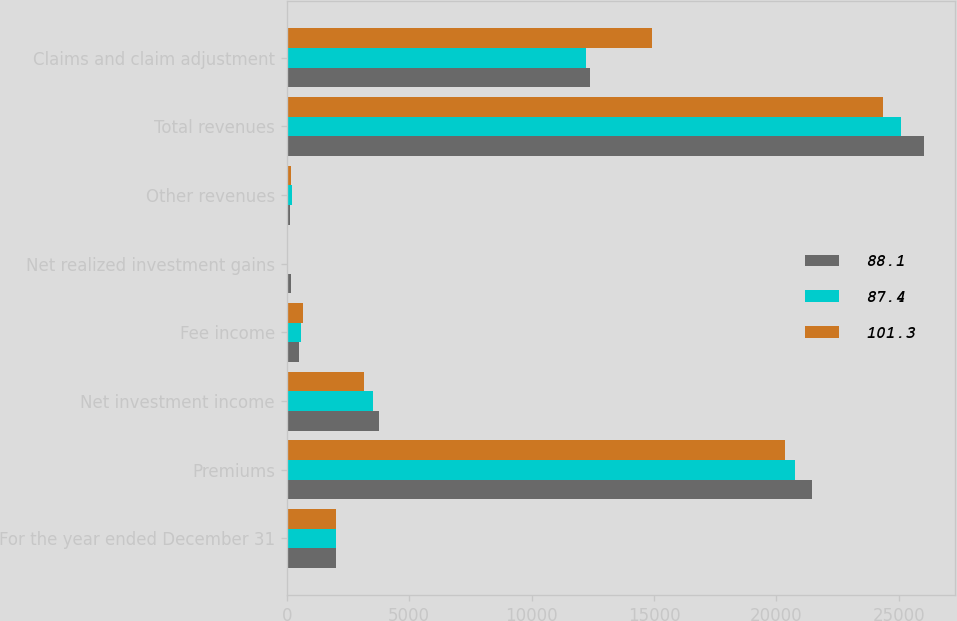<chart> <loc_0><loc_0><loc_500><loc_500><stacked_bar_chart><ecel><fcel>For the year ended December 31<fcel>Premiums<fcel>Net investment income<fcel>Fee income<fcel>Net realized investment gains<fcel>Other revenues<fcel>Total revenues<fcel>Claims and claim adjustment<nl><fcel>88.1<fcel>2007<fcel>21470<fcel>3761<fcel>508<fcel>154<fcel>124<fcel>26017<fcel>12397<nl><fcel>87.4<fcel>2006<fcel>20760<fcel>3517<fcel>591<fcel>11<fcel>211<fcel>25090<fcel>12244<nl><fcel>101.3<fcel>2005<fcel>20341<fcel>3165<fcel>664<fcel>17<fcel>178<fcel>24365<fcel>14927<nl></chart> 